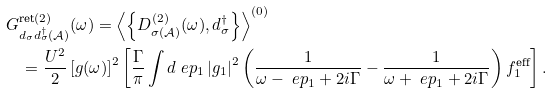<formula> <loc_0><loc_0><loc_500><loc_500>& G ^ { \text {ret} ( 2 ) } _ { d _ { \sigma } d ^ { \dag } _ { \sigma } ( \mathcal { A } ) } ( \omega ) = \left \langle \left \{ D ^ { ( 2 ) } _ { \sigma ( \mathcal { A } ) } ( \omega ) , d ^ { \dag } _ { \sigma } \right \} \right \rangle ^ { ( 0 ) } \\ & \quad = \frac { U ^ { 2 } } { 2 } \left [ g ( \omega ) \right ] ^ { 2 } \left [ \frac { \Gamma } { \pi } \int { d \ e p _ { 1 } } \left | g _ { 1 } \right | ^ { 2 } \left ( \frac { 1 } { \omega - \ e p _ { 1 } + 2 i \Gamma } - \frac { 1 } { \omega + \ e p _ { 1 } + 2 i \Gamma } \right ) f ^ { \text {eff} } _ { 1 } \right ] .</formula> 